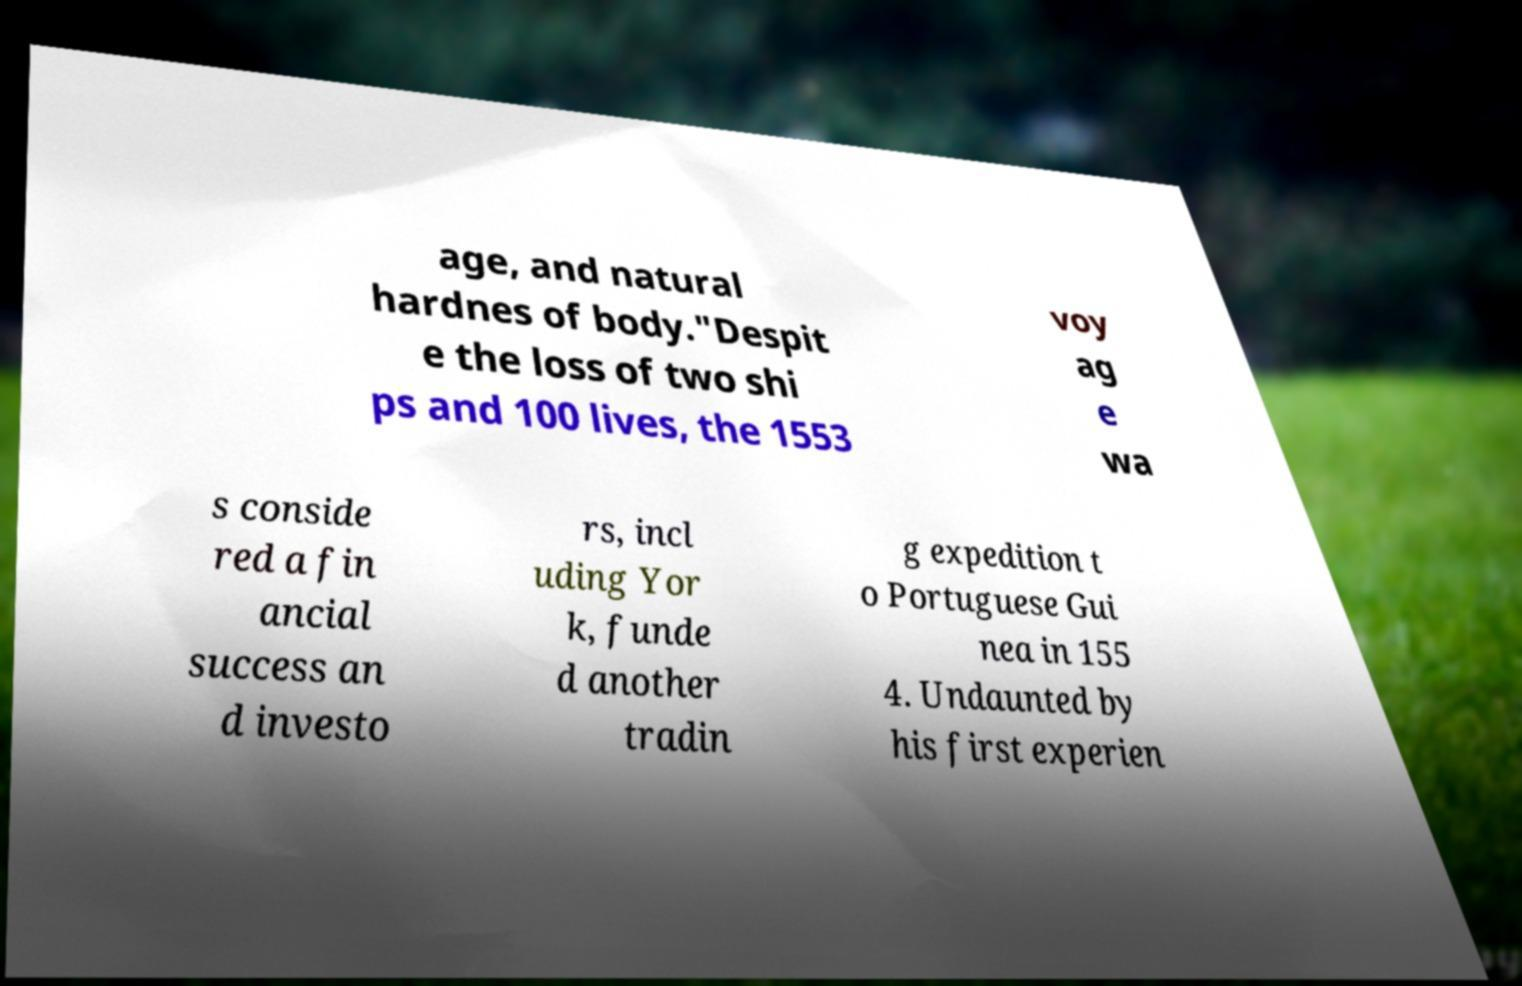I need the written content from this picture converted into text. Can you do that? age, and natural hardnes of body."Despit e the loss of two shi ps and 100 lives, the 1553 voy ag e wa s conside red a fin ancial success an d investo rs, incl uding Yor k, funde d another tradin g expedition t o Portuguese Gui nea in 155 4. Undaunted by his first experien 